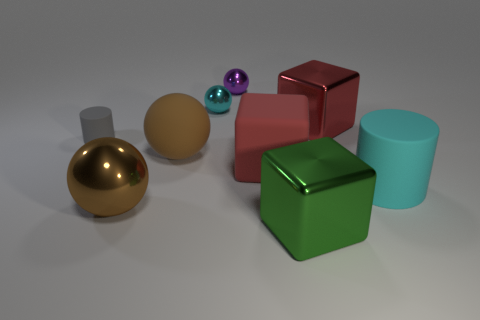How does the lighting in the scene contribute to the perception of the objects? The lighting in the scene appears diffuse, creating gentle shadows and subtle reflections that enhance the three-dimensional quality of the objects without causing harsh glares, thus helping to distinguish the textures and shapes of the materials. 